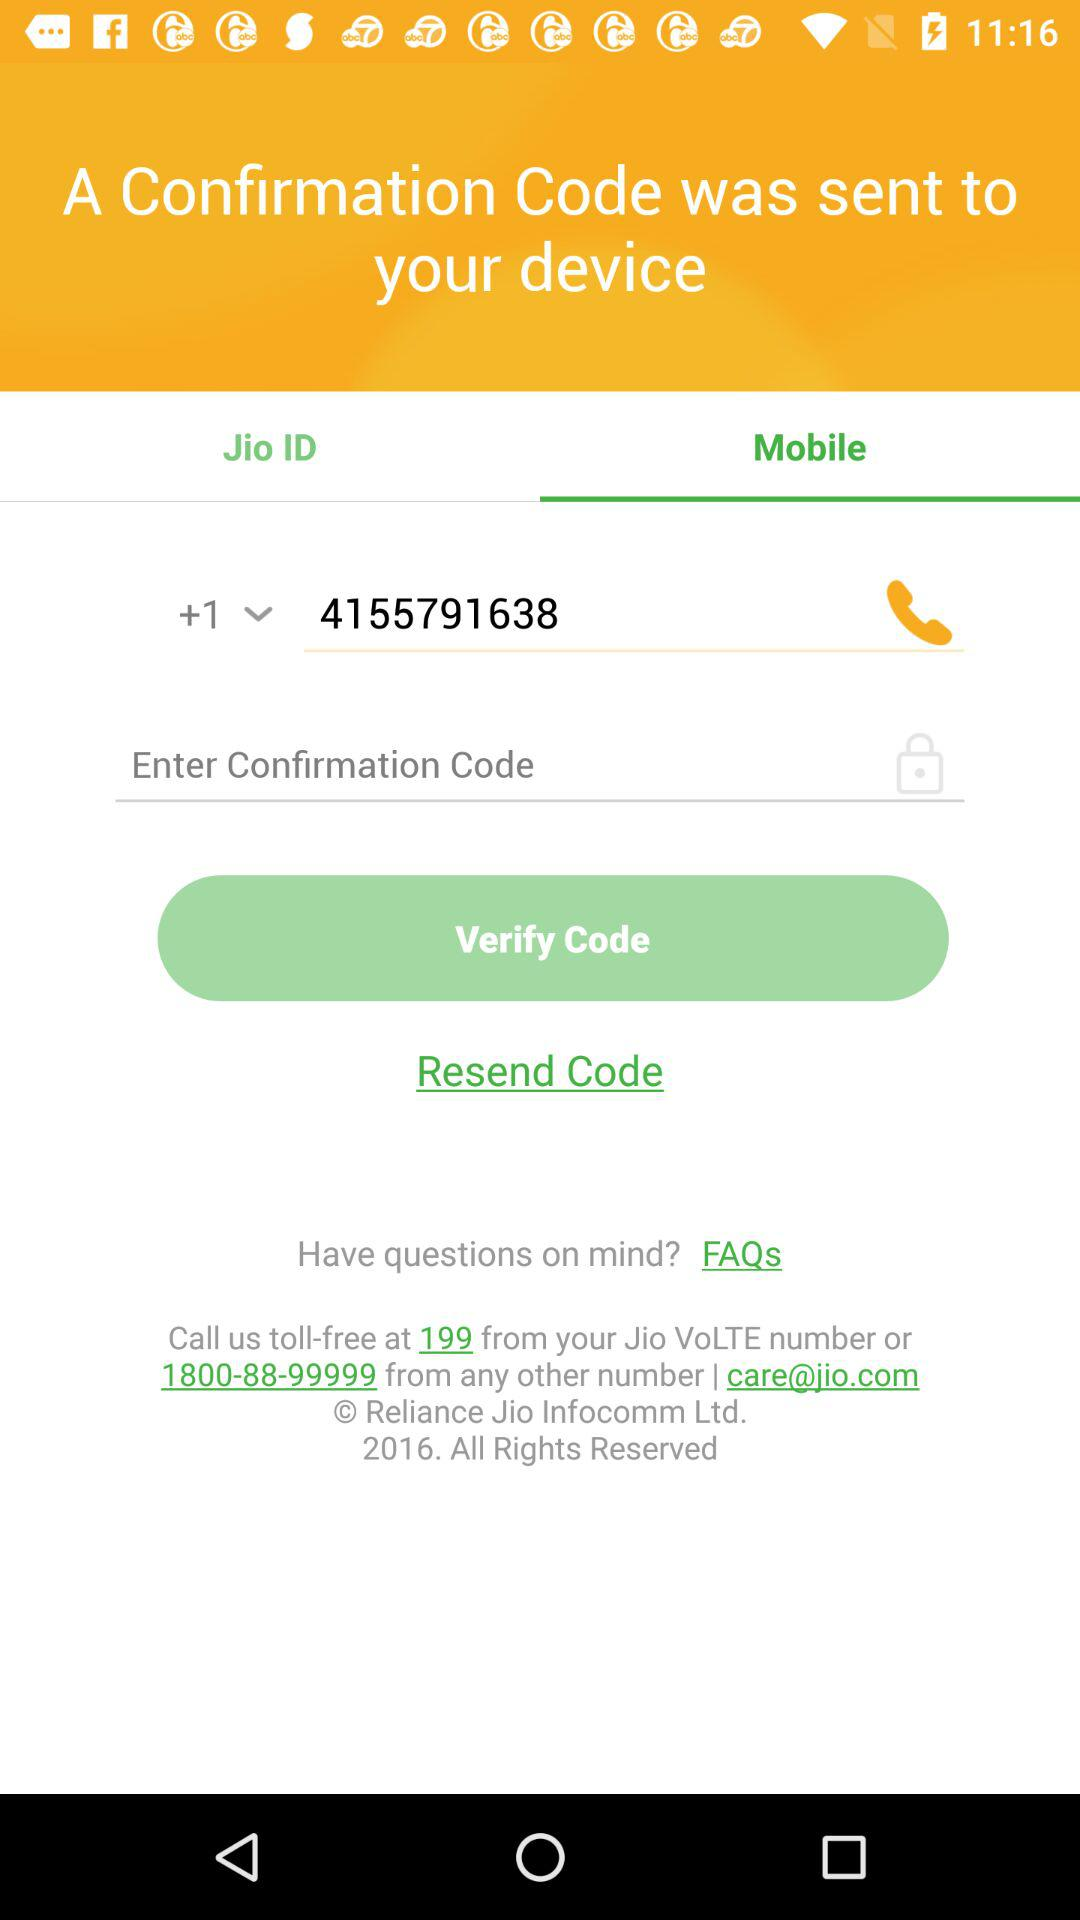What is the email address that I can use for any problems? The email address is care@jio.com. 